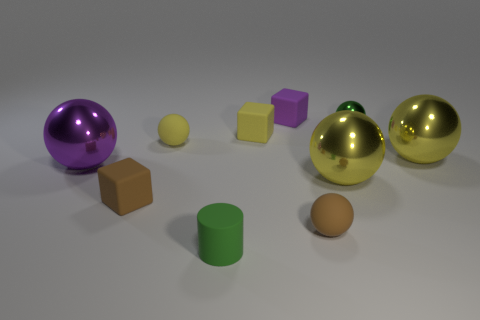How would you describe the mood of this image? The image evokes a serene and clinical mood, with its soft lighting and clean arrangement of objects, giving it a minimalistic and controlled ambiance. 